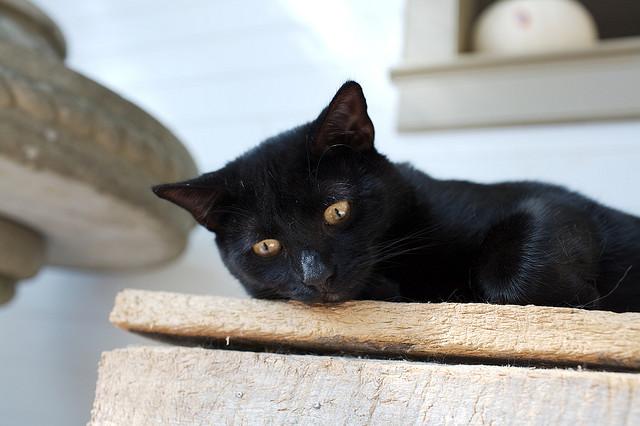What is the cat sitting on?
Short answer required. Wood. Is this cat facing the camera?
Quick response, please. Yes. How many paws is the cat laying on?
Give a very brief answer. 4. What color are the cats eyes?
Concise answer only. Yellow. 